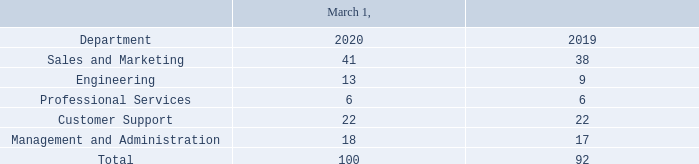Our number of employees is as follows:
On August 3, 2018, we implemented a plan to restructure our organization, which included a reduction in workforce of approximately 40 employees, representing approximately 30% of the Company’s total pre-restructuring workforce. We recorded a charge of $381,000 in the third quarter of 2018 relating to this reduction in force, consisting primarily of one-time severance payments and termination benefits. The Company’s goal in the restructuring is to better focus our workforce on retaining current clients, gaining incremental business from current clients, and winning new business in the market segments where we can leverage our expertise and long history as an EFT pioneer.
Employees
Why did the company restructure their organisation? The company’s goal in the restructuring is to better focus our workforce on retaining current clients, gaining incremental business from current clients, and winning new business in the market segments where we can leverage our expertise and long history as an eft pioneer. Why was there a charge of $381,000 to the company in 2018? We recorded a charge of $381,000 in the third quarter of 2018 relating to this reduction in force, consisting primarily of one-time severance payments and termination benefits. What percentage of the company's pre-restructuring workers were retrenched? Approximately 30% of the company’s total pre-restructuring workforce. What percentage change is the number of employees in the Sales and Marketing department from 2019 to 2020?
Answer scale should be: percent. (41-38)/38
Answer: 7.89. By what percentage did the number of employees in the Engineering department increase from 2019 to 2020?
Answer scale should be: percent. (13-9)/9
Answer: 44.44. How much was the company charged approximately for each employee that was dismissed? $381,000/40
Answer: 9525. 